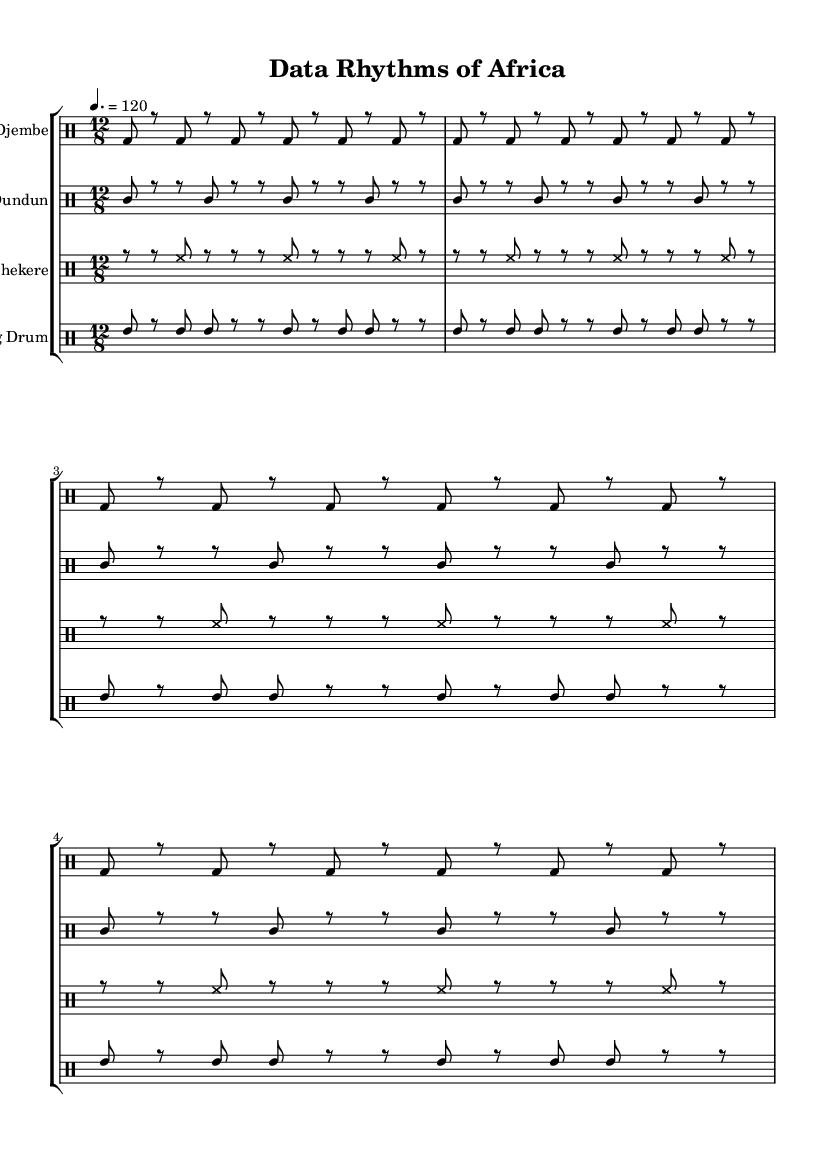What is the time signature of this music? The time signature is indicated at the beginning of the score. It is 12/8, which means there are 12 eighth-note beats in each measure.
Answer: 12/8 What is the tempo of the music? The tempo is specified in beats per minute at the start of the score. It indicates a speed of 120 beats per minute.
Answer: 120 How many measures are there for each percussion part? By examining the music for each percussion instrument, we can see that each section contains 4 measures repeated in the score.
Answer: 4 What is the primary rhythmic element used in the Djembe part? The Djembe part consists primarily of bass drum hits, illustrated by the consistent pattern of 'bd' notes throughout the measures.
Answer: Bass drum Which percussion instrument features high-pitched sounds? The Shekere part includes high-hat notes, indicated by the 'hh' symbols in the sheet music, which are characteristic of high-pitched sounds.
Answer: Shekere What kind of rhythm pattern does the Talking Drum follow? The Talking Drum exhibits a combination of rhythms set by the 'tommh' notation that alternates between played notes and rests, showcasing a unique rhythmic variation.
Answer: Combination 